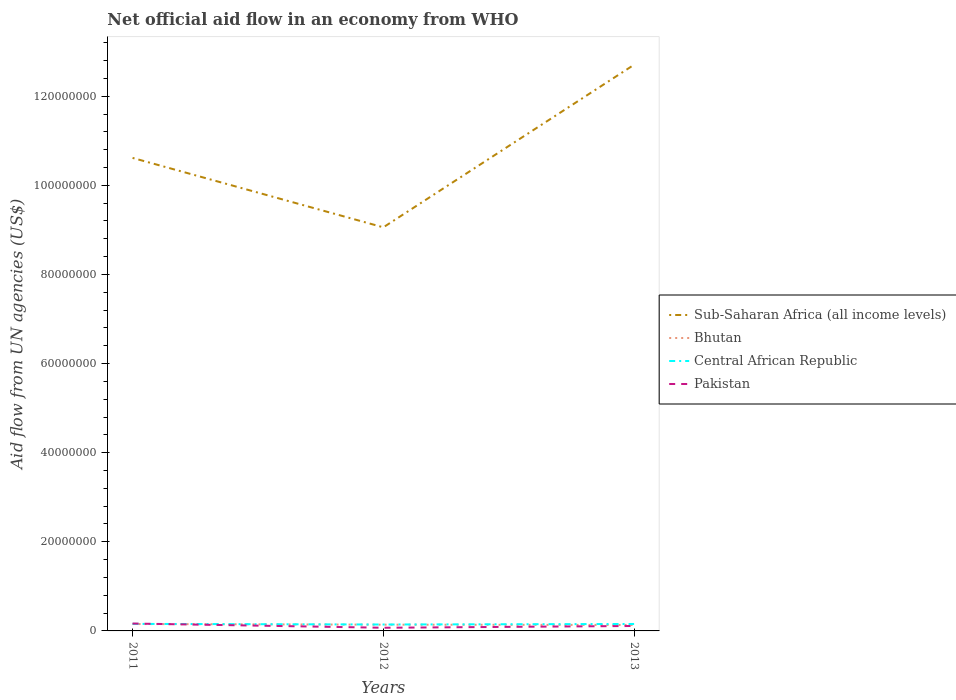Across all years, what is the maximum net official aid flow in Pakistan?
Keep it short and to the point. 7.10e+05. What is the total net official aid flow in Sub-Saharan Africa (all income levels) in the graph?
Your answer should be very brief. 1.56e+07. Is the net official aid flow in Pakistan strictly greater than the net official aid flow in Central African Republic over the years?
Keep it short and to the point. No. How many lines are there?
Provide a short and direct response. 4. What is the difference between two consecutive major ticks on the Y-axis?
Give a very brief answer. 2.00e+07. Are the values on the major ticks of Y-axis written in scientific E-notation?
Your response must be concise. No. What is the title of the graph?
Your answer should be compact. Net official aid flow in an economy from WHO. What is the label or title of the Y-axis?
Provide a succinct answer. Aid flow from UN agencies (US$). What is the Aid flow from UN agencies (US$) in Sub-Saharan Africa (all income levels) in 2011?
Provide a short and direct response. 1.06e+08. What is the Aid flow from UN agencies (US$) in Bhutan in 2011?
Offer a terse response. 1.55e+06. What is the Aid flow from UN agencies (US$) in Central African Republic in 2011?
Your answer should be very brief. 1.58e+06. What is the Aid flow from UN agencies (US$) in Pakistan in 2011?
Your answer should be very brief. 1.66e+06. What is the Aid flow from UN agencies (US$) in Sub-Saharan Africa (all income levels) in 2012?
Offer a very short reply. 9.06e+07. What is the Aid flow from UN agencies (US$) in Bhutan in 2012?
Give a very brief answer. 1.40e+06. What is the Aid flow from UN agencies (US$) of Central African Republic in 2012?
Provide a short and direct response. 1.44e+06. What is the Aid flow from UN agencies (US$) of Pakistan in 2012?
Provide a short and direct response. 7.10e+05. What is the Aid flow from UN agencies (US$) in Sub-Saharan Africa (all income levels) in 2013?
Provide a succinct answer. 1.27e+08. What is the Aid flow from UN agencies (US$) of Bhutan in 2013?
Make the answer very short. 1.34e+06. What is the Aid flow from UN agencies (US$) of Central African Republic in 2013?
Offer a terse response. 1.56e+06. What is the Aid flow from UN agencies (US$) in Pakistan in 2013?
Give a very brief answer. 1.11e+06. Across all years, what is the maximum Aid flow from UN agencies (US$) of Sub-Saharan Africa (all income levels)?
Give a very brief answer. 1.27e+08. Across all years, what is the maximum Aid flow from UN agencies (US$) in Bhutan?
Provide a short and direct response. 1.55e+06. Across all years, what is the maximum Aid flow from UN agencies (US$) of Central African Republic?
Provide a short and direct response. 1.58e+06. Across all years, what is the maximum Aid flow from UN agencies (US$) of Pakistan?
Your response must be concise. 1.66e+06. Across all years, what is the minimum Aid flow from UN agencies (US$) of Sub-Saharan Africa (all income levels)?
Your answer should be very brief. 9.06e+07. Across all years, what is the minimum Aid flow from UN agencies (US$) of Bhutan?
Offer a terse response. 1.34e+06. Across all years, what is the minimum Aid flow from UN agencies (US$) of Central African Republic?
Ensure brevity in your answer.  1.44e+06. Across all years, what is the minimum Aid flow from UN agencies (US$) of Pakistan?
Your answer should be very brief. 7.10e+05. What is the total Aid flow from UN agencies (US$) of Sub-Saharan Africa (all income levels) in the graph?
Your answer should be compact. 3.24e+08. What is the total Aid flow from UN agencies (US$) in Bhutan in the graph?
Offer a terse response. 4.29e+06. What is the total Aid flow from UN agencies (US$) of Central African Republic in the graph?
Keep it short and to the point. 4.58e+06. What is the total Aid flow from UN agencies (US$) in Pakistan in the graph?
Provide a short and direct response. 3.48e+06. What is the difference between the Aid flow from UN agencies (US$) in Sub-Saharan Africa (all income levels) in 2011 and that in 2012?
Offer a terse response. 1.56e+07. What is the difference between the Aid flow from UN agencies (US$) of Central African Republic in 2011 and that in 2012?
Give a very brief answer. 1.40e+05. What is the difference between the Aid flow from UN agencies (US$) of Pakistan in 2011 and that in 2012?
Provide a short and direct response. 9.50e+05. What is the difference between the Aid flow from UN agencies (US$) in Sub-Saharan Africa (all income levels) in 2011 and that in 2013?
Offer a terse response. -2.09e+07. What is the difference between the Aid flow from UN agencies (US$) in Bhutan in 2011 and that in 2013?
Make the answer very short. 2.10e+05. What is the difference between the Aid flow from UN agencies (US$) of Sub-Saharan Africa (all income levels) in 2012 and that in 2013?
Your answer should be very brief. -3.65e+07. What is the difference between the Aid flow from UN agencies (US$) of Bhutan in 2012 and that in 2013?
Your response must be concise. 6.00e+04. What is the difference between the Aid flow from UN agencies (US$) in Central African Republic in 2012 and that in 2013?
Provide a succinct answer. -1.20e+05. What is the difference between the Aid flow from UN agencies (US$) in Pakistan in 2012 and that in 2013?
Keep it short and to the point. -4.00e+05. What is the difference between the Aid flow from UN agencies (US$) in Sub-Saharan Africa (all income levels) in 2011 and the Aid flow from UN agencies (US$) in Bhutan in 2012?
Your answer should be very brief. 1.05e+08. What is the difference between the Aid flow from UN agencies (US$) of Sub-Saharan Africa (all income levels) in 2011 and the Aid flow from UN agencies (US$) of Central African Republic in 2012?
Keep it short and to the point. 1.05e+08. What is the difference between the Aid flow from UN agencies (US$) in Sub-Saharan Africa (all income levels) in 2011 and the Aid flow from UN agencies (US$) in Pakistan in 2012?
Offer a very short reply. 1.05e+08. What is the difference between the Aid flow from UN agencies (US$) of Bhutan in 2011 and the Aid flow from UN agencies (US$) of Central African Republic in 2012?
Keep it short and to the point. 1.10e+05. What is the difference between the Aid flow from UN agencies (US$) of Bhutan in 2011 and the Aid flow from UN agencies (US$) of Pakistan in 2012?
Provide a short and direct response. 8.40e+05. What is the difference between the Aid flow from UN agencies (US$) of Central African Republic in 2011 and the Aid flow from UN agencies (US$) of Pakistan in 2012?
Ensure brevity in your answer.  8.70e+05. What is the difference between the Aid flow from UN agencies (US$) in Sub-Saharan Africa (all income levels) in 2011 and the Aid flow from UN agencies (US$) in Bhutan in 2013?
Your response must be concise. 1.05e+08. What is the difference between the Aid flow from UN agencies (US$) in Sub-Saharan Africa (all income levels) in 2011 and the Aid flow from UN agencies (US$) in Central African Republic in 2013?
Your response must be concise. 1.05e+08. What is the difference between the Aid flow from UN agencies (US$) of Sub-Saharan Africa (all income levels) in 2011 and the Aid flow from UN agencies (US$) of Pakistan in 2013?
Provide a succinct answer. 1.05e+08. What is the difference between the Aid flow from UN agencies (US$) in Bhutan in 2011 and the Aid flow from UN agencies (US$) in Central African Republic in 2013?
Keep it short and to the point. -10000. What is the difference between the Aid flow from UN agencies (US$) of Bhutan in 2011 and the Aid flow from UN agencies (US$) of Pakistan in 2013?
Offer a very short reply. 4.40e+05. What is the difference between the Aid flow from UN agencies (US$) of Central African Republic in 2011 and the Aid flow from UN agencies (US$) of Pakistan in 2013?
Keep it short and to the point. 4.70e+05. What is the difference between the Aid flow from UN agencies (US$) in Sub-Saharan Africa (all income levels) in 2012 and the Aid flow from UN agencies (US$) in Bhutan in 2013?
Offer a very short reply. 8.92e+07. What is the difference between the Aid flow from UN agencies (US$) in Sub-Saharan Africa (all income levels) in 2012 and the Aid flow from UN agencies (US$) in Central African Republic in 2013?
Your answer should be very brief. 8.90e+07. What is the difference between the Aid flow from UN agencies (US$) in Sub-Saharan Africa (all income levels) in 2012 and the Aid flow from UN agencies (US$) in Pakistan in 2013?
Provide a succinct answer. 8.95e+07. What is the difference between the Aid flow from UN agencies (US$) of Bhutan in 2012 and the Aid flow from UN agencies (US$) of Central African Republic in 2013?
Your response must be concise. -1.60e+05. What is the difference between the Aid flow from UN agencies (US$) of Central African Republic in 2012 and the Aid flow from UN agencies (US$) of Pakistan in 2013?
Make the answer very short. 3.30e+05. What is the average Aid flow from UN agencies (US$) in Sub-Saharan Africa (all income levels) per year?
Offer a very short reply. 1.08e+08. What is the average Aid flow from UN agencies (US$) in Bhutan per year?
Provide a short and direct response. 1.43e+06. What is the average Aid flow from UN agencies (US$) in Central African Republic per year?
Offer a terse response. 1.53e+06. What is the average Aid flow from UN agencies (US$) of Pakistan per year?
Your response must be concise. 1.16e+06. In the year 2011, what is the difference between the Aid flow from UN agencies (US$) of Sub-Saharan Africa (all income levels) and Aid flow from UN agencies (US$) of Bhutan?
Your answer should be compact. 1.05e+08. In the year 2011, what is the difference between the Aid flow from UN agencies (US$) of Sub-Saharan Africa (all income levels) and Aid flow from UN agencies (US$) of Central African Republic?
Provide a succinct answer. 1.05e+08. In the year 2011, what is the difference between the Aid flow from UN agencies (US$) in Sub-Saharan Africa (all income levels) and Aid flow from UN agencies (US$) in Pakistan?
Provide a short and direct response. 1.04e+08. In the year 2011, what is the difference between the Aid flow from UN agencies (US$) of Central African Republic and Aid flow from UN agencies (US$) of Pakistan?
Ensure brevity in your answer.  -8.00e+04. In the year 2012, what is the difference between the Aid flow from UN agencies (US$) in Sub-Saharan Africa (all income levels) and Aid flow from UN agencies (US$) in Bhutan?
Provide a short and direct response. 8.92e+07. In the year 2012, what is the difference between the Aid flow from UN agencies (US$) in Sub-Saharan Africa (all income levels) and Aid flow from UN agencies (US$) in Central African Republic?
Provide a succinct answer. 8.91e+07. In the year 2012, what is the difference between the Aid flow from UN agencies (US$) in Sub-Saharan Africa (all income levels) and Aid flow from UN agencies (US$) in Pakistan?
Ensure brevity in your answer.  8.99e+07. In the year 2012, what is the difference between the Aid flow from UN agencies (US$) of Bhutan and Aid flow from UN agencies (US$) of Pakistan?
Your response must be concise. 6.90e+05. In the year 2012, what is the difference between the Aid flow from UN agencies (US$) of Central African Republic and Aid flow from UN agencies (US$) of Pakistan?
Your answer should be compact. 7.30e+05. In the year 2013, what is the difference between the Aid flow from UN agencies (US$) of Sub-Saharan Africa (all income levels) and Aid flow from UN agencies (US$) of Bhutan?
Offer a terse response. 1.26e+08. In the year 2013, what is the difference between the Aid flow from UN agencies (US$) in Sub-Saharan Africa (all income levels) and Aid flow from UN agencies (US$) in Central African Republic?
Keep it short and to the point. 1.26e+08. In the year 2013, what is the difference between the Aid flow from UN agencies (US$) in Sub-Saharan Africa (all income levels) and Aid flow from UN agencies (US$) in Pakistan?
Give a very brief answer. 1.26e+08. In the year 2013, what is the difference between the Aid flow from UN agencies (US$) of Central African Republic and Aid flow from UN agencies (US$) of Pakistan?
Provide a succinct answer. 4.50e+05. What is the ratio of the Aid flow from UN agencies (US$) in Sub-Saharan Africa (all income levels) in 2011 to that in 2012?
Your answer should be compact. 1.17. What is the ratio of the Aid flow from UN agencies (US$) in Bhutan in 2011 to that in 2012?
Your answer should be compact. 1.11. What is the ratio of the Aid flow from UN agencies (US$) in Central African Republic in 2011 to that in 2012?
Provide a succinct answer. 1.1. What is the ratio of the Aid flow from UN agencies (US$) of Pakistan in 2011 to that in 2012?
Your answer should be compact. 2.34. What is the ratio of the Aid flow from UN agencies (US$) in Sub-Saharan Africa (all income levels) in 2011 to that in 2013?
Your answer should be very brief. 0.84. What is the ratio of the Aid flow from UN agencies (US$) in Bhutan in 2011 to that in 2013?
Offer a terse response. 1.16. What is the ratio of the Aid flow from UN agencies (US$) in Central African Republic in 2011 to that in 2013?
Your response must be concise. 1.01. What is the ratio of the Aid flow from UN agencies (US$) in Pakistan in 2011 to that in 2013?
Keep it short and to the point. 1.5. What is the ratio of the Aid flow from UN agencies (US$) in Sub-Saharan Africa (all income levels) in 2012 to that in 2013?
Ensure brevity in your answer.  0.71. What is the ratio of the Aid flow from UN agencies (US$) in Bhutan in 2012 to that in 2013?
Keep it short and to the point. 1.04. What is the ratio of the Aid flow from UN agencies (US$) of Pakistan in 2012 to that in 2013?
Provide a succinct answer. 0.64. What is the difference between the highest and the second highest Aid flow from UN agencies (US$) in Sub-Saharan Africa (all income levels)?
Keep it short and to the point. 2.09e+07. What is the difference between the highest and the second highest Aid flow from UN agencies (US$) in Bhutan?
Provide a succinct answer. 1.50e+05. What is the difference between the highest and the lowest Aid flow from UN agencies (US$) of Sub-Saharan Africa (all income levels)?
Offer a very short reply. 3.65e+07. What is the difference between the highest and the lowest Aid flow from UN agencies (US$) of Pakistan?
Provide a succinct answer. 9.50e+05. 